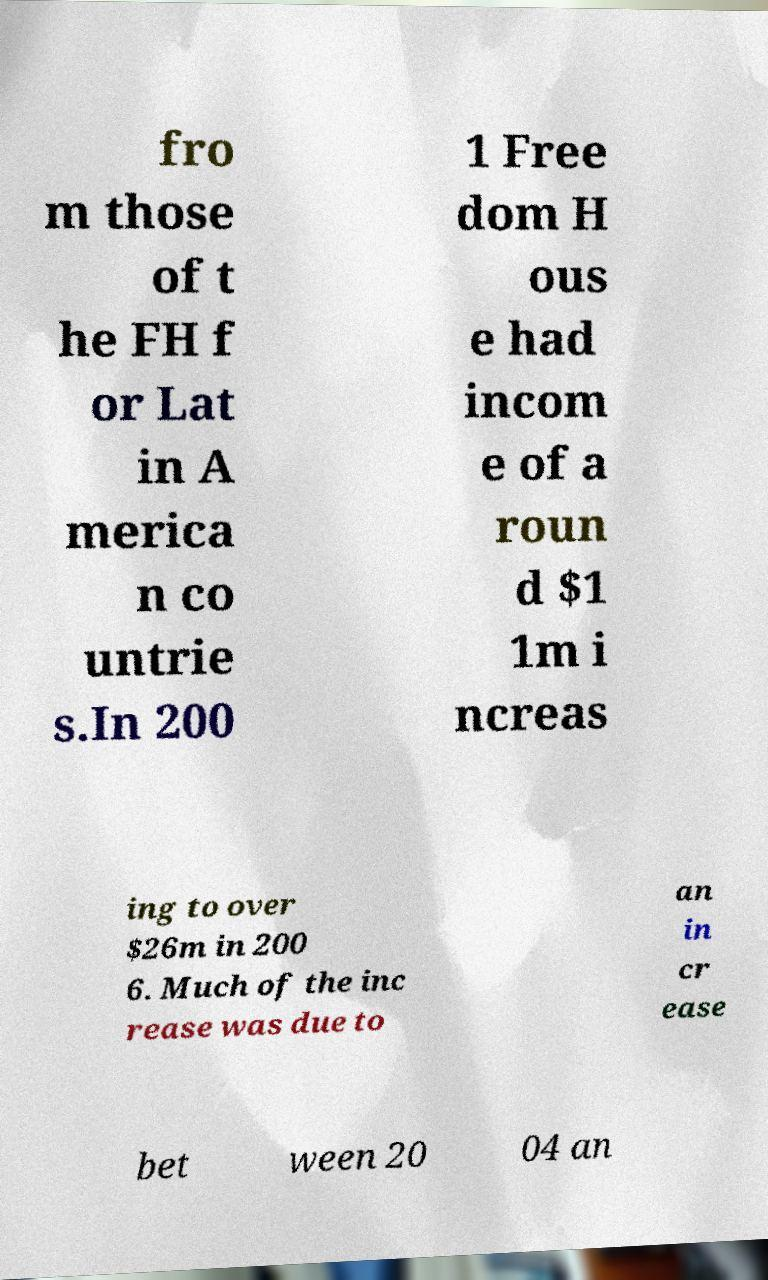Can you read and provide the text displayed in the image?This photo seems to have some interesting text. Can you extract and type it out for me? fro m those of t he FH f or Lat in A merica n co untrie s.In 200 1 Free dom H ous e had incom e of a roun d $1 1m i ncreas ing to over $26m in 200 6. Much of the inc rease was due to an in cr ease bet ween 20 04 an 